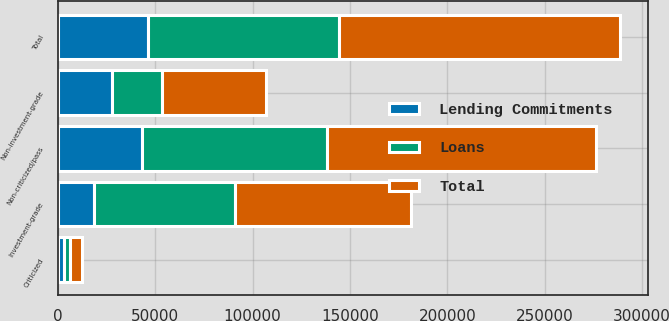<chart> <loc_0><loc_0><loc_500><loc_500><stacked_bar_chart><ecel><fcel>Investment-grade<fcel>Non-investment-grade<fcel>Total<fcel>Non-criticized/pass<fcel>Criticized<nl><fcel>Lending Commitments<fcel>18434<fcel>27777<fcel>46211<fcel>43146<fcel>3065<nl><fcel>Loans<fcel>72323<fcel>25722<fcel>98045<fcel>94966<fcel>3079<nl><fcel>Total<fcel>90757<fcel>53499<fcel>144256<fcel>138112<fcel>6144<nl></chart> 